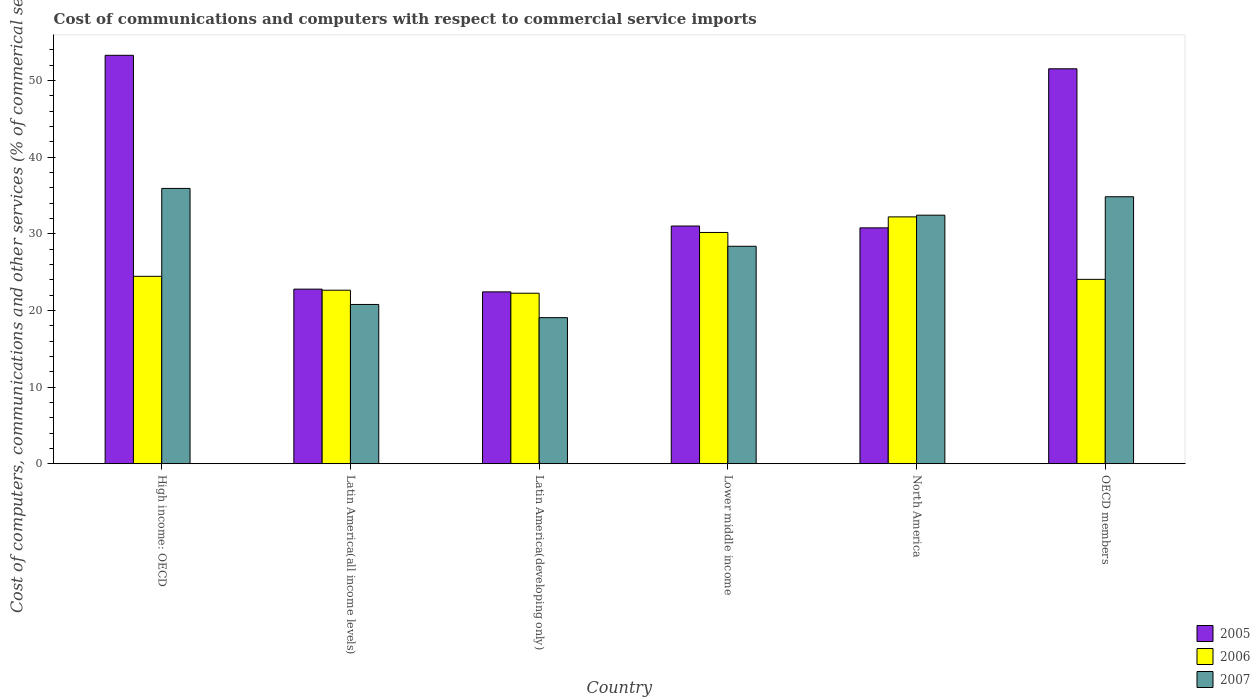Are the number of bars per tick equal to the number of legend labels?
Your answer should be compact. Yes. Are the number of bars on each tick of the X-axis equal?
Your answer should be compact. Yes. How many bars are there on the 5th tick from the left?
Provide a short and direct response. 3. What is the label of the 4th group of bars from the left?
Provide a short and direct response. Lower middle income. In how many cases, is the number of bars for a given country not equal to the number of legend labels?
Offer a very short reply. 0. What is the cost of communications and computers in 2007 in OECD members?
Offer a very short reply. 34.82. Across all countries, what is the maximum cost of communications and computers in 2006?
Give a very brief answer. 32.2. Across all countries, what is the minimum cost of communications and computers in 2005?
Make the answer very short. 22.42. In which country was the cost of communications and computers in 2007 maximum?
Make the answer very short. High income: OECD. In which country was the cost of communications and computers in 2007 minimum?
Provide a succinct answer. Latin America(developing only). What is the total cost of communications and computers in 2007 in the graph?
Your answer should be compact. 171.34. What is the difference between the cost of communications and computers in 2007 in High income: OECD and that in Lower middle income?
Provide a succinct answer. 7.55. What is the difference between the cost of communications and computers in 2005 in Lower middle income and the cost of communications and computers in 2007 in High income: OECD?
Your answer should be very brief. -4.9. What is the average cost of communications and computers in 2007 per country?
Ensure brevity in your answer.  28.56. What is the difference between the cost of communications and computers of/in 2005 and cost of communications and computers of/in 2006 in Latin America(all income levels)?
Make the answer very short. 0.14. What is the ratio of the cost of communications and computers in 2006 in Lower middle income to that in North America?
Offer a terse response. 0.94. What is the difference between the highest and the second highest cost of communications and computers in 2007?
Offer a terse response. -2.4. What is the difference between the highest and the lowest cost of communications and computers in 2007?
Provide a short and direct response. 16.85. What does the 3rd bar from the left in Latin America(developing only) represents?
Give a very brief answer. 2007. What does the 2nd bar from the right in Latin America(developing only) represents?
Ensure brevity in your answer.  2006. How many countries are there in the graph?
Your answer should be compact. 6. How many legend labels are there?
Provide a succinct answer. 3. How are the legend labels stacked?
Provide a succinct answer. Vertical. What is the title of the graph?
Give a very brief answer. Cost of communications and computers with respect to commercial service imports. Does "1975" appear as one of the legend labels in the graph?
Make the answer very short. No. What is the label or title of the Y-axis?
Offer a terse response. Cost of computers, communications and other services (% of commerical service exports). What is the Cost of computers, communications and other services (% of commerical service exports) in 2005 in High income: OECD?
Offer a very short reply. 53.27. What is the Cost of computers, communications and other services (% of commerical service exports) in 2006 in High income: OECD?
Ensure brevity in your answer.  24.45. What is the Cost of computers, communications and other services (% of commerical service exports) of 2007 in High income: OECD?
Ensure brevity in your answer.  35.91. What is the Cost of computers, communications and other services (% of commerical service exports) in 2005 in Latin America(all income levels)?
Make the answer very short. 22.77. What is the Cost of computers, communications and other services (% of commerical service exports) in 2006 in Latin America(all income levels)?
Your answer should be very brief. 22.63. What is the Cost of computers, communications and other services (% of commerical service exports) in 2007 in Latin America(all income levels)?
Your answer should be compact. 20.77. What is the Cost of computers, communications and other services (% of commerical service exports) of 2005 in Latin America(developing only)?
Make the answer very short. 22.42. What is the Cost of computers, communications and other services (% of commerical service exports) of 2006 in Latin America(developing only)?
Offer a terse response. 22.24. What is the Cost of computers, communications and other services (% of commerical service exports) in 2007 in Latin America(developing only)?
Make the answer very short. 19.05. What is the Cost of computers, communications and other services (% of commerical service exports) of 2005 in Lower middle income?
Make the answer very short. 31. What is the Cost of computers, communications and other services (% of commerical service exports) in 2006 in Lower middle income?
Your answer should be compact. 30.16. What is the Cost of computers, communications and other services (% of commerical service exports) of 2007 in Lower middle income?
Your answer should be very brief. 28.36. What is the Cost of computers, communications and other services (% of commerical service exports) in 2005 in North America?
Offer a very short reply. 30.77. What is the Cost of computers, communications and other services (% of commerical service exports) of 2006 in North America?
Give a very brief answer. 32.2. What is the Cost of computers, communications and other services (% of commerical service exports) of 2007 in North America?
Offer a terse response. 32.42. What is the Cost of computers, communications and other services (% of commerical service exports) of 2005 in OECD members?
Your answer should be compact. 51.51. What is the Cost of computers, communications and other services (% of commerical service exports) of 2006 in OECD members?
Your answer should be very brief. 24.05. What is the Cost of computers, communications and other services (% of commerical service exports) in 2007 in OECD members?
Keep it short and to the point. 34.82. Across all countries, what is the maximum Cost of computers, communications and other services (% of commerical service exports) in 2005?
Provide a short and direct response. 53.27. Across all countries, what is the maximum Cost of computers, communications and other services (% of commerical service exports) in 2006?
Keep it short and to the point. 32.2. Across all countries, what is the maximum Cost of computers, communications and other services (% of commerical service exports) in 2007?
Ensure brevity in your answer.  35.91. Across all countries, what is the minimum Cost of computers, communications and other services (% of commerical service exports) of 2005?
Your answer should be compact. 22.42. Across all countries, what is the minimum Cost of computers, communications and other services (% of commerical service exports) in 2006?
Offer a very short reply. 22.24. Across all countries, what is the minimum Cost of computers, communications and other services (% of commerical service exports) of 2007?
Make the answer very short. 19.05. What is the total Cost of computers, communications and other services (% of commerical service exports) of 2005 in the graph?
Offer a very short reply. 211.74. What is the total Cost of computers, communications and other services (% of commerical service exports) in 2006 in the graph?
Your answer should be very brief. 155.73. What is the total Cost of computers, communications and other services (% of commerical service exports) in 2007 in the graph?
Your answer should be compact. 171.34. What is the difference between the Cost of computers, communications and other services (% of commerical service exports) of 2005 in High income: OECD and that in Latin America(all income levels)?
Your response must be concise. 30.5. What is the difference between the Cost of computers, communications and other services (% of commerical service exports) of 2006 in High income: OECD and that in Latin America(all income levels)?
Give a very brief answer. 1.81. What is the difference between the Cost of computers, communications and other services (% of commerical service exports) in 2007 in High income: OECD and that in Latin America(all income levels)?
Your response must be concise. 15.14. What is the difference between the Cost of computers, communications and other services (% of commerical service exports) of 2005 in High income: OECD and that in Latin America(developing only)?
Your response must be concise. 30.86. What is the difference between the Cost of computers, communications and other services (% of commerical service exports) in 2006 in High income: OECD and that in Latin America(developing only)?
Your answer should be very brief. 2.21. What is the difference between the Cost of computers, communications and other services (% of commerical service exports) of 2007 in High income: OECD and that in Latin America(developing only)?
Your response must be concise. 16.85. What is the difference between the Cost of computers, communications and other services (% of commerical service exports) of 2005 in High income: OECD and that in Lower middle income?
Provide a short and direct response. 22.27. What is the difference between the Cost of computers, communications and other services (% of commerical service exports) of 2006 in High income: OECD and that in Lower middle income?
Offer a terse response. -5.72. What is the difference between the Cost of computers, communications and other services (% of commerical service exports) in 2007 in High income: OECD and that in Lower middle income?
Offer a very short reply. 7.55. What is the difference between the Cost of computers, communications and other services (% of commerical service exports) of 2005 in High income: OECD and that in North America?
Your response must be concise. 22.51. What is the difference between the Cost of computers, communications and other services (% of commerical service exports) in 2006 in High income: OECD and that in North America?
Your answer should be very brief. -7.75. What is the difference between the Cost of computers, communications and other services (% of commerical service exports) of 2007 in High income: OECD and that in North America?
Your answer should be very brief. 3.49. What is the difference between the Cost of computers, communications and other services (% of commerical service exports) of 2005 in High income: OECD and that in OECD members?
Offer a very short reply. 1.76. What is the difference between the Cost of computers, communications and other services (% of commerical service exports) in 2006 in High income: OECD and that in OECD members?
Ensure brevity in your answer.  0.4. What is the difference between the Cost of computers, communications and other services (% of commerical service exports) of 2007 in High income: OECD and that in OECD members?
Provide a succinct answer. 1.09. What is the difference between the Cost of computers, communications and other services (% of commerical service exports) in 2005 in Latin America(all income levels) and that in Latin America(developing only)?
Keep it short and to the point. 0.36. What is the difference between the Cost of computers, communications and other services (% of commerical service exports) of 2006 in Latin America(all income levels) and that in Latin America(developing only)?
Offer a terse response. 0.39. What is the difference between the Cost of computers, communications and other services (% of commerical service exports) of 2007 in Latin America(all income levels) and that in Latin America(developing only)?
Make the answer very short. 1.72. What is the difference between the Cost of computers, communications and other services (% of commerical service exports) in 2005 in Latin America(all income levels) and that in Lower middle income?
Offer a very short reply. -8.23. What is the difference between the Cost of computers, communications and other services (% of commerical service exports) of 2006 in Latin America(all income levels) and that in Lower middle income?
Your answer should be very brief. -7.53. What is the difference between the Cost of computers, communications and other services (% of commerical service exports) in 2007 in Latin America(all income levels) and that in Lower middle income?
Ensure brevity in your answer.  -7.59. What is the difference between the Cost of computers, communications and other services (% of commerical service exports) of 2005 in Latin America(all income levels) and that in North America?
Keep it short and to the point. -7.99. What is the difference between the Cost of computers, communications and other services (% of commerical service exports) in 2006 in Latin America(all income levels) and that in North America?
Give a very brief answer. -9.56. What is the difference between the Cost of computers, communications and other services (% of commerical service exports) of 2007 in Latin America(all income levels) and that in North America?
Provide a short and direct response. -11.64. What is the difference between the Cost of computers, communications and other services (% of commerical service exports) in 2005 in Latin America(all income levels) and that in OECD members?
Your response must be concise. -28.74. What is the difference between the Cost of computers, communications and other services (% of commerical service exports) of 2006 in Latin America(all income levels) and that in OECD members?
Your answer should be very brief. -1.42. What is the difference between the Cost of computers, communications and other services (% of commerical service exports) in 2007 in Latin America(all income levels) and that in OECD members?
Your response must be concise. -14.05. What is the difference between the Cost of computers, communications and other services (% of commerical service exports) in 2005 in Latin America(developing only) and that in Lower middle income?
Offer a very short reply. -8.59. What is the difference between the Cost of computers, communications and other services (% of commerical service exports) of 2006 in Latin America(developing only) and that in Lower middle income?
Provide a succinct answer. -7.93. What is the difference between the Cost of computers, communications and other services (% of commerical service exports) of 2007 in Latin America(developing only) and that in Lower middle income?
Offer a terse response. -9.31. What is the difference between the Cost of computers, communications and other services (% of commerical service exports) of 2005 in Latin America(developing only) and that in North America?
Offer a very short reply. -8.35. What is the difference between the Cost of computers, communications and other services (% of commerical service exports) of 2006 in Latin America(developing only) and that in North America?
Your answer should be very brief. -9.96. What is the difference between the Cost of computers, communications and other services (% of commerical service exports) in 2007 in Latin America(developing only) and that in North America?
Make the answer very short. -13.36. What is the difference between the Cost of computers, communications and other services (% of commerical service exports) of 2005 in Latin America(developing only) and that in OECD members?
Your response must be concise. -29.1. What is the difference between the Cost of computers, communications and other services (% of commerical service exports) of 2006 in Latin America(developing only) and that in OECD members?
Ensure brevity in your answer.  -1.81. What is the difference between the Cost of computers, communications and other services (% of commerical service exports) in 2007 in Latin America(developing only) and that in OECD members?
Your answer should be compact. -15.77. What is the difference between the Cost of computers, communications and other services (% of commerical service exports) in 2005 in Lower middle income and that in North America?
Ensure brevity in your answer.  0.24. What is the difference between the Cost of computers, communications and other services (% of commerical service exports) in 2006 in Lower middle income and that in North America?
Give a very brief answer. -2.03. What is the difference between the Cost of computers, communications and other services (% of commerical service exports) in 2007 in Lower middle income and that in North America?
Offer a terse response. -4.05. What is the difference between the Cost of computers, communications and other services (% of commerical service exports) in 2005 in Lower middle income and that in OECD members?
Keep it short and to the point. -20.51. What is the difference between the Cost of computers, communications and other services (% of commerical service exports) of 2006 in Lower middle income and that in OECD members?
Make the answer very short. 6.12. What is the difference between the Cost of computers, communications and other services (% of commerical service exports) of 2007 in Lower middle income and that in OECD members?
Provide a succinct answer. -6.46. What is the difference between the Cost of computers, communications and other services (% of commerical service exports) in 2005 in North America and that in OECD members?
Ensure brevity in your answer.  -20.75. What is the difference between the Cost of computers, communications and other services (% of commerical service exports) in 2006 in North America and that in OECD members?
Keep it short and to the point. 8.15. What is the difference between the Cost of computers, communications and other services (% of commerical service exports) in 2007 in North America and that in OECD members?
Provide a short and direct response. -2.4. What is the difference between the Cost of computers, communications and other services (% of commerical service exports) of 2005 in High income: OECD and the Cost of computers, communications and other services (% of commerical service exports) of 2006 in Latin America(all income levels)?
Offer a terse response. 30.64. What is the difference between the Cost of computers, communications and other services (% of commerical service exports) in 2005 in High income: OECD and the Cost of computers, communications and other services (% of commerical service exports) in 2007 in Latin America(all income levels)?
Your answer should be very brief. 32.5. What is the difference between the Cost of computers, communications and other services (% of commerical service exports) of 2006 in High income: OECD and the Cost of computers, communications and other services (% of commerical service exports) of 2007 in Latin America(all income levels)?
Provide a succinct answer. 3.67. What is the difference between the Cost of computers, communications and other services (% of commerical service exports) in 2005 in High income: OECD and the Cost of computers, communications and other services (% of commerical service exports) in 2006 in Latin America(developing only)?
Your answer should be very brief. 31.03. What is the difference between the Cost of computers, communications and other services (% of commerical service exports) of 2005 in High income: OECD and the Cost of computers, communications and other services (% of commerical service exports) of 2007 in Latin America(developing only)?
Your response must be concise. 34.22. What is the difference between the Cost of computers, communications and other services (% of commerical service exports) of 2006 in High income: OECD and the Cost of computers, communications and other services (% of commerical service exports) of 2007 in Latin America(developing only)?
Offer a terse response. 5.39. What is the difference between the Cost of computers, communications and other services (% of commerical service exports) of 2005 in High income: OECD and the Cost of computers, communications and other services (% of commerical service exports) of 2006 in Lower middle income?
Keep it short and to the point. 23.11. What is the difference between the Cost of computers, communications and other services (% of commerical service exports) in 2005 in High income: OECD and the Cost of computers, communications and other services (% of commerical service exports) in 2007 in Lower middle income?
Make the answer very short. 24.91. What is the difference between the Cost of computers, communications and other services (% of commerical service exports) in 2006 in High income: OECD and the Cost of computers, communications and other services (% of commerical service exports) in 2007 in Lower middle income?
Keep it short and to the point. -3.92. What is the difference between the Cost of computers, communications and other services (% of commerical service exports) of 2005 in High income: OECD and the Cost of computers, communications and other services (% of commerical service exports) of 2006 in North America?
Your response must be concise. 21.08. What is the difference between the Cost of computers, communications and other services (% of commerical service exports) of 2005 in High income: OECD and the Cost of computers, communications and other services (% of commerical service exports) of 2007 in North America?
Your answer should be compact. 20.85. What is the difference between the Cost of computers, communications and other services (% of commerical service exports) of 2006 in High income: OECD and the Cost of computers, communications and other services (% of commerical service exports) of 2007 in North America?
Keep it short and to the point. -7.97. What is the difference between the Cost of computers, communications and other services (% of commerical service exports) of 2005 in High income: OECD and the Cost of computers, communications and other services (% of commerical service exports) of 2006 in OECD members?
Your answer should be very brief. 29.22. What is the difference between the Cost of computers, communications and other services (% of commerical service exports) in 2005 in High income: OECD and the Cost of computers, communications and other services (% of commerical service exports) in 2007 in OECD members?
Provide a short and direct response. 18.45. What is the difference between the Cost of computers, communications and other services (% of commerical service exports) of 2006 in High income: OECD and the Cost of computers, communications and other services (% of commerical service exports) of 2007 in OECD members?
Your answer should be compact. -10.38. What is the difference between the Cost of computers, communications and other services (% of commerical service exports) in 2005 in Latin America(all income levels) and the Cost of computers, communications and other services (% of commerical service exports) in 2006 in Latin America(developing only)?
Keep it short and to the point. 0.53. What is the difference between the Cost of computers, communications and other services (% of commerical service exports) in 2005 in Latin America(all income levels) and the Cost of computers, communications and other services (% of commerical service exports) in 2007 in Latin America(developing only)?
Offer a very short reply. 3.72. What is the difference between the Cost of computers, communications and other services (% of commerical service exports) in 2006 in Latin America(all income levels) and the Cost of computers, communications and other services (% of commerical service exports) in 2007 in Latin America(developing only)?
Offer a terse response. 3.58. What is the difference between the Cost of computers, communications and other services (% of commerical service exports) in 2005 in Latin America(all income levels) and the Cost of computers, communications and other services (% of commerical service exports) in 2006 in Lower middle income?
Ensure brevity in your answer.  -7.39. What is the difference between the Cost of computers, communications and other services (% of commerical service exports) in 2005 in Latin America(all income levels) and the Cost of computers, communications and other services (% of commerical service exports) in 2007 in Lower middle income?
Your response must be concise. -5.59. What is the difference between the Cost of computers, communications and other services (% of commerical service exports) of 2006 in Latin America(all income levels) and the Cost of computers, communications and other services (% of commerical service exports) of 2007 in Lower middle income?
Your answer should be very brief. -5.73. What is the difference between the Cost of computers, communications and other services (% of commerical service exports) of 2005 in Latin America(all income levels) and the Cost of computers, communications and other services (% of commerical service exports) of 2006 in North America?
Keep it short and to the point. -9.42. What is the difference between the Cost of computers, communications and other services (% of commerical service exports) in 2005 in Latin America(all income levels) and the Cost of computers, communications and other services (% of commerical service exports) in 2007 in North America?
Provide a short and direct response. -9.65. What is the difference between the Cost of computers, communications and other services (% of commerical service exports) of 2006 in Latin America(all income levels) and the Cost of computers, communications and other services (% of commerical service exports) of 2007 in North America?
Provide a succinct answer. -9.79. What is the difference between the Cost of computers, communications and other services (% of commerical service exports) of 2005 in Latin America(all income levels) and the Cost of computers, communications and other services (% of commerical service exports) of 2006 in OECD members?
Keep it short and to the point. -1.28. What is the difference between the Cost of computers, communications and other services (% of commerical service exports) in 2005 in Latin America(all income levels) and the Cost of computers, communications and other services (% of commerical service exports) in 2007 in OECD members?
Provide a succinct answer. -12.05. What is the difference between the Cost of computers, communications and other services (% of commerical service exports) in 2006 in Latin America(all income levels) and the Cost of computers, communications and other services (% of commerical service exports) in 2007 in OECD members?
Provide a succinct answer. -12.19. What is the difference between the Cost of computers, communications and other services (% of commerical service exports) in 2005 in Latin America(developing only) and the Cost of computers, communications and other services (% of commerical service exports) in 2006 in Lower middle income?
Make the answer very short. -7.75. What is the difference between the Cost of computers, communications and other services (% of commerical service exports) of 2005 in Latin America(developing only) and the Cost of computers, communications and other services (% of commerical service exports) of 2007 in Lower middle income?
Offer a terse response. -5.95. What is the difference between the Cost of computers, communications and other services (% of commerical service exports) in 2006 in Latin America(developing only) and the Cost of computers, communications and other services (% of commerical service exports) in 2007 in Lower middle income?
Your answer should be very brief. -6.12. What is the difference between the Cost of computers, communications and other services (% of commerical service exports) in 2005 in Latin America(developing only) and the Cost of computers, communications and other services (% of commerical service exports) in 2006 in North America?
Ensure brevity in your answer.  -9.78. What is the difference between the Cost of computers, communications and other services (% of commerical service exports) of 2005 in Latin America(developing only) and the Cost of computers, communications and other services (% of commerical service exports) of 2007 in North America?
Keep it short and to the point. -10. What is the difference between the Cost of computers, communications and other services (% of commerical service exports) of 2006 in Latin America(developing only) and the Cost of computers, communications and other services (% of commerical service exports) of 2007 in North America?
Ensure brevity in your answer.  -10.18. What is the difference between the Cost of computers, communications and other services (% of commerical service exports) of 2005 in Latin America(developing only) and the Cost of computers, communications and other services (% of commerical service exports) of 2006 in OECD members?
Ensure brevity in your answer.  -1.63. What is the difference between the Cost of computers, communications and other services (% of commerical service exports) in 2005 in Latin America(developing only) and the Cost of computers, communications and other services (% of commerical service exports) in 2007 in OECD members?
Give a very brief answer. -12.41. What is the difference between the Cost of computers, communications and other services (% of commerical service exports) in 2006 in Latin America(developing only) and the Cost of computers, communications and other services (% of commerical service exports) in 2007 in OECD members?
Ensure brevity in your answer.  -12.58. What is the difference between the Cost of computers, communications and other services (% of commerical service exports) in 2005 in Lower middle income and the Cost of computers, communications and other services (% of commerical service exports) in 2006 in North America?
Your response must be concise. -1.19. What is the difference between the Cost of computers, communications and other services (% of commerical service exports) of 2005 in Lower middle income and the Cost of computers, communications and other services (% of commerical service exports) of 2007 in North America?
Make the answer very short. -1.41. What is the difference between the Cost of computers, communications and other services (% of commerical service exports) in 2006 in Lower middle income and the Cost of computers, communications and other services (% of commerical service exports) in 2007 in North America?
Keep it short and to the point. -2.25. What is the difference between the Cost of computers, communications and other services (% of commerical service exports) of 2005 in Lower middle income and the Cost of computers, communications and other services (% of commerical service exports) of 2006 in OECD members?
Provide a short and direct response. 6.96. What is the difference between the Cost of computers, communications and other services (% of commerical service exports) of 2005 in Lower middle income and the Cost of computers, communications and other services (% of commerical service exports) of 2007 in OECD members?
Your response must be concise. -3.82. What is the difference between the Cost of computers, communications and other services (% of commerical service exports) in 2006 in Lower middle income and the Cost of computers, communications and other services (% of commerical service exports) in 2007 in OECD members?
Your response must be concise. -4.66. What is the difference between the Cost of computers, communications and other services (% of commerical service exports) of 2005 in North America and the Cost of computers, communications and other services (% of commerical service exports) of 2006 in OECD members?
Provide a short and direct response. 6.72. What is the difference between the Cost of computers, communications and other services (% of commerical service exports) in 2005 in North America and the Cost of computers, communications and other services (% of commerical service exports) in 2007 in OECD members?
Offer a very short reply. -4.06. What is the difference between the Cost of computers, communications and other services (% of commerical service exports) of 2006 in North America and the Cost of computers, communications and other services (% of commerical service exports) of 2007 in OECD members?
Keep it short and to the point. -2.63. What is the average Cost of computers, communications and other services (% of commerical service exports) in 2005 per country?
Provide a short and direct response. 35.29. What is the average Cost of computers, communications and other services (% of commerical service exports) in 2006 per country?
Ensure brevity in your answer.  25.95. What is the average Cost of computers, communications and other services (% of commerical service exports) in 2007 per country?
Your response must be concise. 28.56. What is the difference between the Cost of computers, communications and other services (% of commerical service exports) of 2005 and Cost of computers, communications and other services (% of commerical service exports) of 2006 in High income: OECD?
Offer a very short reply. 28.83. What is the difference between the Cost of computers, communications and other services (% of commerical service exports) in 2005 and Cost of computers, communications and other services (% of commerical service exports) in 2007 in High income: OECD?
Offer a terse response. 17.36. What is the difference between the Cost of computers, communications and other services (% of commerical service exports) in 2006 and Cost of computers, communications and other services (% of commerical service exports) in 2007 in High income: OECD?
Your answer should be compact. -11.46. What is the difference between the Cost of computers, communications and other services (% of commerical service exports) of 2005 and Cost of computers, communications and other services (% of commerical service exports) of 2006 in Latin America(all income levels)?
Give a very brief answer. 0.14. What is the difference between the Cost of computers, communications and other services (% of commerical service exports) of 2005 and Cost of computers, communications and other services (% of commerical service exports) of 2007 in Latin America(all income levels)?
Ensure brevity in your answer.  2. What is the difference between the Cost of computers, communications and other services (% of commerical service exports) in 2006 and Cost of computers, communications and other services (% of commerical service exports) in 2007 in Latin America(all income levels)?
Provide a succinct answer. 1.86. What is the difference between the Cost of computers, communications and other services (% of commerical service exports) in 2005 and Cost of computers, communications and other services (% of commerical service exports) in 2006 in Latin America(developing only)?
Offer a terse response. 0.18. What is the difference between the Cost of computers, communications and other services (% of commerical service exports) in 2005 and Cost of computers, communications and other services (% of commerical service exports) in 2007 in Latin America(developing only)?
Give a very brief answer. 3.36. What is the difference between the Cost of computers, communications and other services (% of commerical service exports) in 2006 and Cost of computers, communications and other services (% of commerical service exports) in 2007 in Latin America(developing only)?
Provide a short and direct response. 3.18. What is the difference between the Cost of computers, communications and other services (% of commerical service exports) in 2005 and Cost of computers, communications and other services (% of commerical service exports) in 2006 in Lower middle income?
Your answer should be compact. 0.84. What is the difference between the Cost of computers, communications and other services (% of commerical service exports) in 2005 and Cost of computers, communications and other services (% of commerical service exports) in 2007 in Lower middle income?
Provide a succinct answer. 2.64. What is the difference between the Cost of computers, communications and other services (% of commerical service exports) in 2006 and Cost of computers, communications and other services (% of commerical service exports) in 2007 in Lower middle income?
Make the answer very short. 1.8. What is the difference between the Cost of computers, communications and other services (% of commerical service exports) in 2005 and Cost of computers, communications and other services (% of commerical service exports) in 2006 in North America?
Your answer should be compact. -1.43. What is the difference between the Cost of computers, communications and other services (% of commerical service exports) in 2005 and Cost of computers, communications and other services (% of commerical service exports) in 2007 in North America?
Provide a short and direct response. -1.65. What is the difference between the Cost of computers, communications and other services (% of commerical service exports) in 2006 and Cost of computers, communications and other services (% of commerical service exports) in 2007 in North America?
Offer a terse response. -0.22. What is the difference between the Cost of computers, communications and other services (% of commerical service exports) in 2005 and Cost of computers, communications and other services (% of commerical service exports) in 2006 in OECD members?
Offer a very short reply. 27.46. What is the difference between the Cost of computers, communications and other services (% of commerical service exports) in 2005 and Cost of computers, communications and other services (% of commerical service exports) in 2007 in OECD members?
Your answer should be very brief. 16.69. What is the difference between the Cost of computers, communications and other services (% of commerical service exports) of 2006 and Cost of computers, communications and other services (% of commerical service exports) of 2007 in OECD members?
Make the answer very short. -10.77. What is the ratio of the Cost of computers, communications and other services (% of commerical service exports) of 2005 in High income: OECD to that in Latin America(all income levels)?
Ensure brevity in your answer.  2.34. What is the ratio of the Cost of computers, communications and other services (% of commerical service exports) of 2006 in High income: OECD to that in Latin America(all income levels)?
Provide a succinct answer. 1.08. What is the ratio of the Cost of computers, communications and other services (% of commerical service exports) in 2007 in High income: OECD to that in Latin America(all income levels)?
Your answer should be compact. 1.73. What is the ratio of the Cost of computers, communications and other services (% of commerical service exports) in 2005 in High income: OECD to that in Latin America(developing only)?
Offer a terse response. 2.38. What is the ratio of the Cost of computers, communications and other services (% of commerical service exports) in 2006 in High income: OECD to that in Latin America(developing only)?
Your response must be concise. 1.1. What is the ratio of the Cost of computers, communications and other services (% of commerical service exports) in 2007 in High income: OECD to that in Latin America(developing only)?
Your answer should be compact. 1.88. What is the ratio of the Cost of computers, communications and other services (% of commerical service exports) of 2005 in High income: OECD to that in Lower middle income?
Keep it short and to the point. 1.72. What is the ratio of the Cost of computers, communications and other services (% of commerical service exports) of 2006 in High income: OECD to that in Lower middle income?
Your answer should be very brief. 0.81. What is the ratio of the Cost of computers, communications and other services (% of commerical service exports) of 2007 in High income: OECD to that in Lower middle income?
Offer a terse response. 1.27. What is the ratio of the Cost of computers, communications and other services (% of commerical service exports) in 2005 in High income: OECD to that in North America?
Ensure brevity in your answer.  1.73. What is the ratio of the Cost of computers, communications and other services (% of commerical service exports) in 2006 in High income: OECD to that in North America?
Offer a terse response. 0.76. What is the ratio of the Cost of computers, communications and other services (% of commerical service exports) in 2007 in High income: OECD to that in North America?
Provide a short and direct response. 1.11. What is the ratio of the Cost of computers, communications and other services (% of commerical service exports) in 2005 in High income: OECD to that in OECD members?
Provide a short and direct response. 1.03. What is the ratio of the Cost of computers, communications and other services (% of commerical service exports) of 2006 in High income: OECD to that in OECD members?
Give a very brief answer. 1.02. What is the ratio of the Cost of computers, communications and other services (% of commerical service exports) in 2007 in High income: OECD to that in OECD members?
Give a very brief answer. 1.03. What is the ratio of the Cost of computers, communications and other services (% of commerical service exports) of 2005 in Latin America(all income levels) to that in Latin America(developing only)?
Provide a short and direct response. 1.02. What is the ratio of the Cost of computers, communications and other services (% of commerical service exports) in 2006 in Latin America(all income levels) to that in Latin America(developing only)?
Keep it short and to the point. 1.02. What is the ratio of the Cost of computers, communications and other services (% of commerical service exports) in 2007 in Latin America(all income levels) to that in Latin America(developing only)?
Your answer should be compact. 1.09. What is the ratio of the Cost of computers, communications and other services (% of commerical service exports) of 2005 in Latin America(all income levels) to that in Lower middle income?
Your answer should be compact. 0.73. What is the ratio of the Cost of computers, communications and other services (% of commerical service exports) of 2006 in Latin America(all income levels) to that in Lower middle income?
Offer a terse response. 0.75. What is the ratio of the Cost of computers, communications and other services (% of commerical service exports) of 2007 in Latin America(all income levels) to that in Lower middle income?
Your answer should be very brief. 0.73. What is the ratio of the Cost of computers, communications and other services (% of commerical service exports) in 2005 in Latin America(all income levels) to that in North America?
Your response must be concise. 0.74. What is the ratio of the Cost of computers, communications and other services (% of commerical service exports) of 2006 in Latin America(all income levels) to that in North America?
Offer a very short reply. 0.7. What is the ratio of the Cost of computers, communications and other services (% of commerical service exports) of 2007 in Latin America(all income levels) to that in North America?
Provide a short and direct response. 0.64. What is the ratio of the Cost of computers, communications and other services (% of commerical service exports) of 2005 in Latin America(all income levels) to that in OECD members?
Offer a very short reply. 0.44. What is the ratio of the Cost of computers, communications and other services (% of commerical service exports) of 2006 in Latin America(all income levels) to that in OECD members?
Provide a short and direct response. 0.94. What is the ratio of the Cost of computers, communications and other services (% of commerical service exports) in 2007 in Latin America(all income levels) to that in OECD members?
Offer a terse response. 0.6. What is the ratio of the Cost of computers, communications and other services (% of commerical service exports) of 2005 in Latin America(developing only) to that in Lower middle income?
Your answer should be compact. 0.72. What is the ratio of the Cost of computers, communications and other services (% of commerical service exports) in 2006 in Latin America(developing only) to that in Lower middle income?
Ensure brevity in your answer.  0.74. What is the ratio of the Cost of computers, communications and other services (% of commerical service exports) in 2007 in Latin America(developing only) to that in Lower middle income?
Keep it short and to the point. 0.67. What is the ratio of the Cost of computers, communications and other services (% of commerical service exports) in 2005 in Latin America(developing only) to that in North America?
Give a very brief answer. 0.73. What is the ratio of the Cost of computers, communications and other services (% of commerical service exports) of 2006 in Latin America(developing only) to that in North America?
Give a very brief answer. 0.69. What is the ratio of the Cost of computers, communications and other services (% of commerical service exports) in 2007 in Latin America(developing only) to that in North America?
Provide a short and direct response. 0.59. What is the ratio of the Cost of computers, communications and other services (% of commerical service exports) of 2005 in Latin America(developing only) to that in OECD members?
Your answer should be very brief. 0.44. What is the ratio of the Cost of computers, communications and other services (% of commerical service exports) in 2006 in Latin America(developing only) to that in OECD members?
Provide a short and direct response. 0.92. What is the ratio of the Cost of computers, communications and other services (% of commerical service exports) of 2007 in Latin America(developing only) to that in OECD members?
Your answer should be compact. 0.55. What is the ratio of the Cost of computers, communications and other services (% of commerical service exports) in 2006 in Lower middle income to that in North America?
Provide a succinct answer. 0.94. What is the ratio of the Cost of computers, communications and other services (% of commerical service exports) in 2007 in Lower middle income to that in North America?
Ensure brevity in your answer.  0.87. What is the ratio of the Cost of computers, communications and other services (% of commerical service exports) of 2005 in Lower middle income to that in OECD members?
Give a very brief answer. 0.6. What is the ratio of the Cost of computers, communications and other services (% of commerical service exports) of 2006 in Lower middle income to that in OECD members?
Make the answer very short. 1.25. What is the ratio of the Cost of computers, communications and other services (% of commerical service exports) in 2007 in Lower middle income to that in OECD members?
Offer a terse response. 0.81. What is the ratio of the Cost of computers, communications and other services (% of commerical service exports) of 2005 in North America to that in OECD members?
Offer a very short reply. 0.6. What is the ratio of the Cost of computers, communications and other services (% of commerical service exports) of 2006 in North America to that in OECD members?
Provide a short and direct response. 1.34. What is the difference between the highest and the second highest Cost of computers, communications and other services (% of commerical service exports) in 2005?
Your response must be concise. 1.76. What is the difference between the highest and the second highest Cost of computers, communications and other services (% of commerical service exports) in 2006?
Offer a terse response. 2.03. What is the difference between the highest and the second highest Cost of computers, communications and other services (% of commerical service exports) of 2007?
Your answer should be compact. 1.09. What is the difference between the highest and the lowest Cost of computers, communications and other services (% of commerical service exports) in 2005?
Your answer should be compact. 30.86. What is the difference between the highest and the lowest Cost of computers, communications and other services (% of commerical service exports) of 2006?
Your answer should be very brief. 9.96. What is the difference between the highest and the lowest Cost of computers, communications and other services (% of commerical service exports) of 2007?
Ensure brevity in your answer.  16.85. 